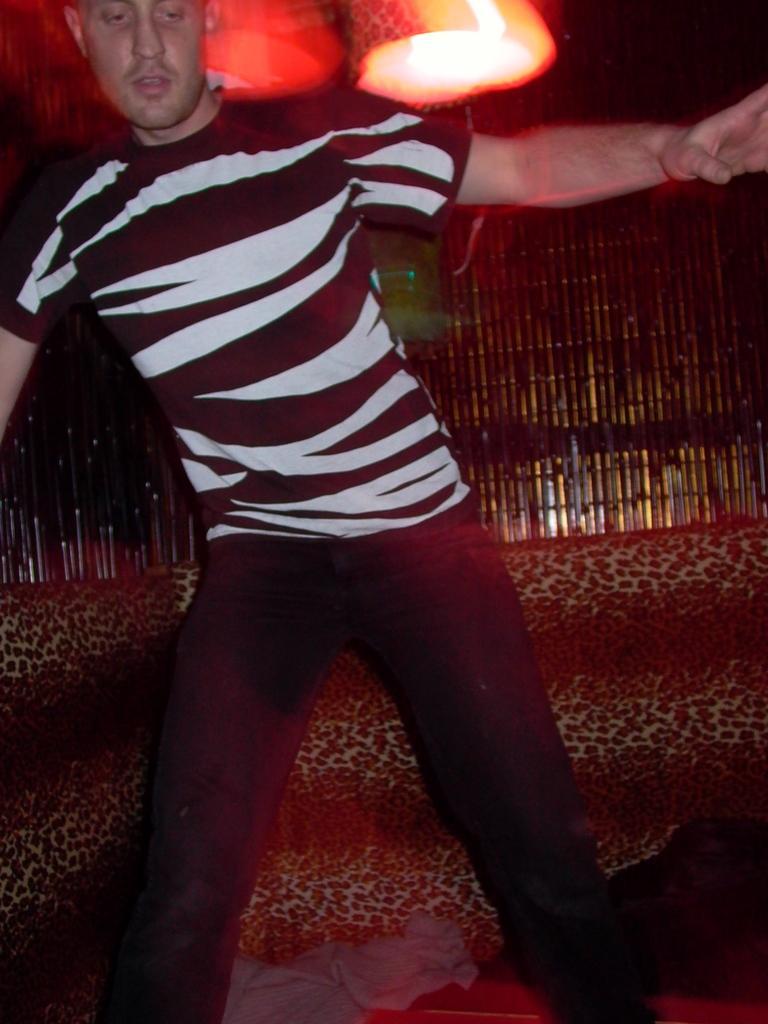In one or two sentences, can you explain what this image depicts? In this image, we can see a man standing and there is a light at the top. 